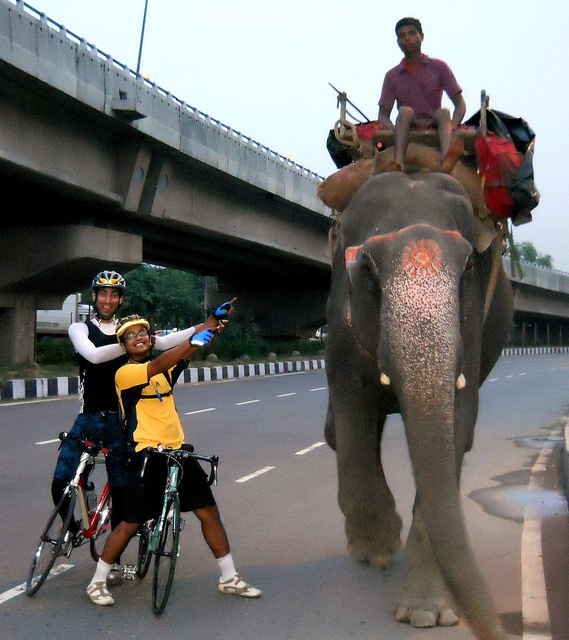Describe the objects in this image and their specific colors. I can see elephant in gray and black tones, people in gray, black, lavender, and darkgray tones, people in gray, black, maroon, and orange tones, people in gray, maroon, purple, and black tones, and bicycle in gray, black, maroon, and white tones in this image. 